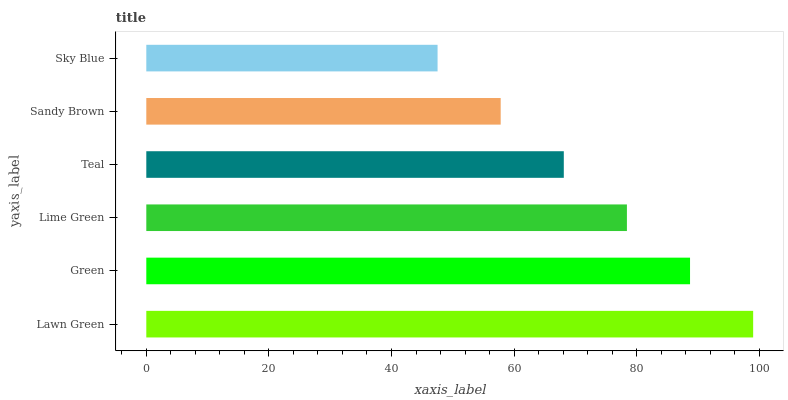Is Sky Blue the minimum?
Answer yes or no. Yes. Is Lawn Green the maximum?
Answer yes or no. Yes. Is Green the minimum?
Answer yes or no. No. Is Green the maximum?
Answer yes or no. No. Is Lawn Green greater than Green?
Answer yes or no. Yes. Is Green less than Lawn Green?
Answer yes or no. Yes. Is Green greater than Lawn Green?
Answer yes or no. No. Is Lawn Green less than Green?
Answer yes or no. No. Is Lime Green the high median?
Answer yes or no. Yes. Is Teal the low median?
Answer yes or no. Yes. Is Green the high median?
Answer yes or no. No. Is Sandy Brown the low median?
Answer yes or no. No. 